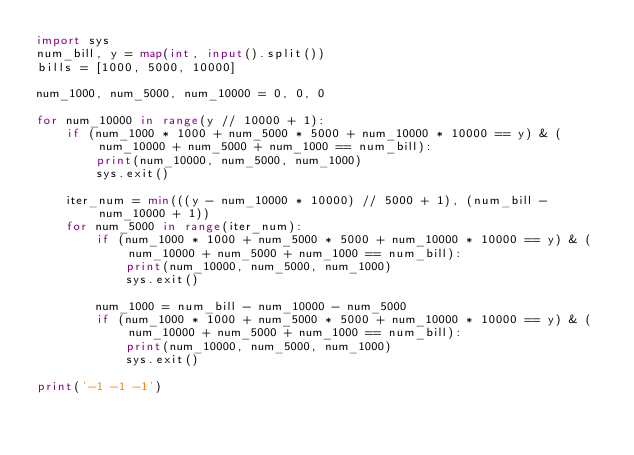Convert code to text. <code><loc_0><loc_0><loc_500><loc_500><_Python_>import sys
num_bill, y = map(int, input().split())
bills = [1000, 5000, 10000]

num_1000, num_5000, num_10000 = 0, 0, 0

for num_10000 in range(y // 10000 + 1):
    if (num_1000 * 1000 + num_5000 * 5000 + num_10000 * 10000 == y) & (num_10000 + num_5000 + num_1000 == num_bill):
        print(num_10000, num_5000, num_1000)
        sys.exit()
        
    iter_num = min(((y - num_10000 * 10000) // 5000 + 1), (num_bill - num_10000 + 1))
    for num_5000 in range(iter_num):
        if (num_1000 * 1000 + num_5000 * 5000 + num_10000 * 10000 == y) & (num_10000 + num_5000 + num_1000 == num_bill):
            print(num_10000, num_5000, num_1000)
            sys.exit()
        
        num_1000 = num_bill - num_10000 - num_5000
        if (num_1000 * 1000 + num_5000 * 5000 + num_10000 * 10000 == y) & (num_10000 + num_5000 + num_1000 == num_bill):
            print(num_10000, num_5000, num_1000)
            sys.exit()

print('-1 -1 -1')</code> 